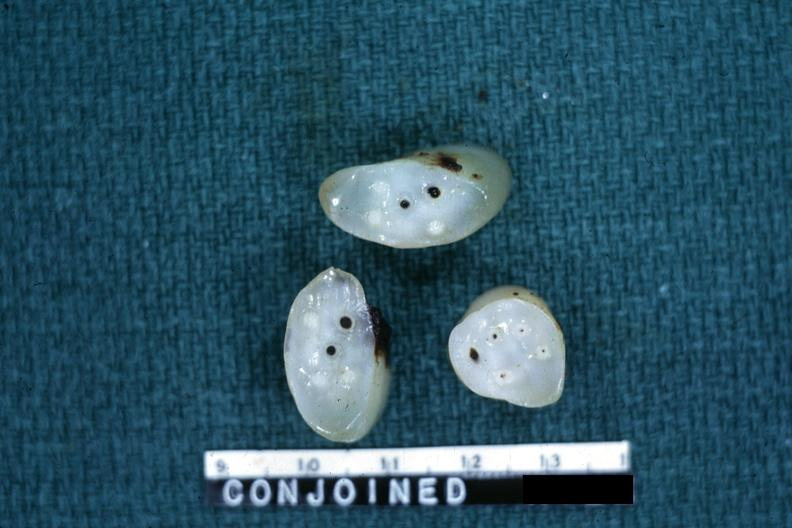what is present?
Answer the question using a single word or phrase. Siamese twins 